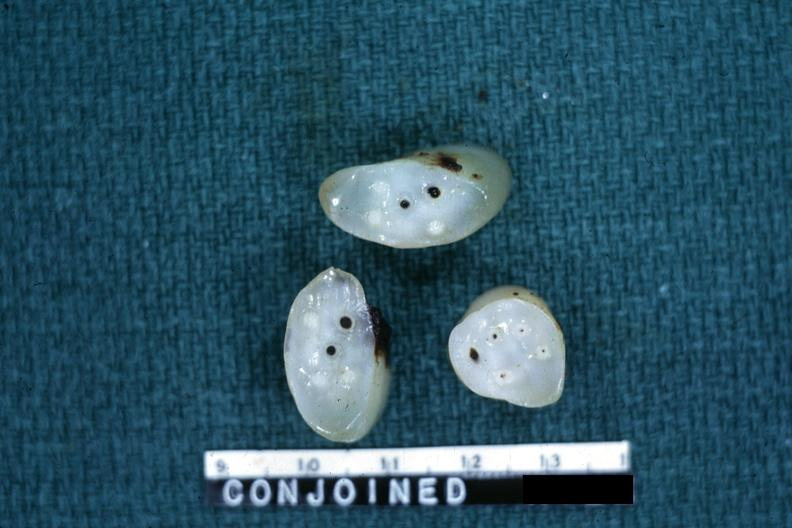what is present?
Answer the question using a single word or phrase. Siamese twins 